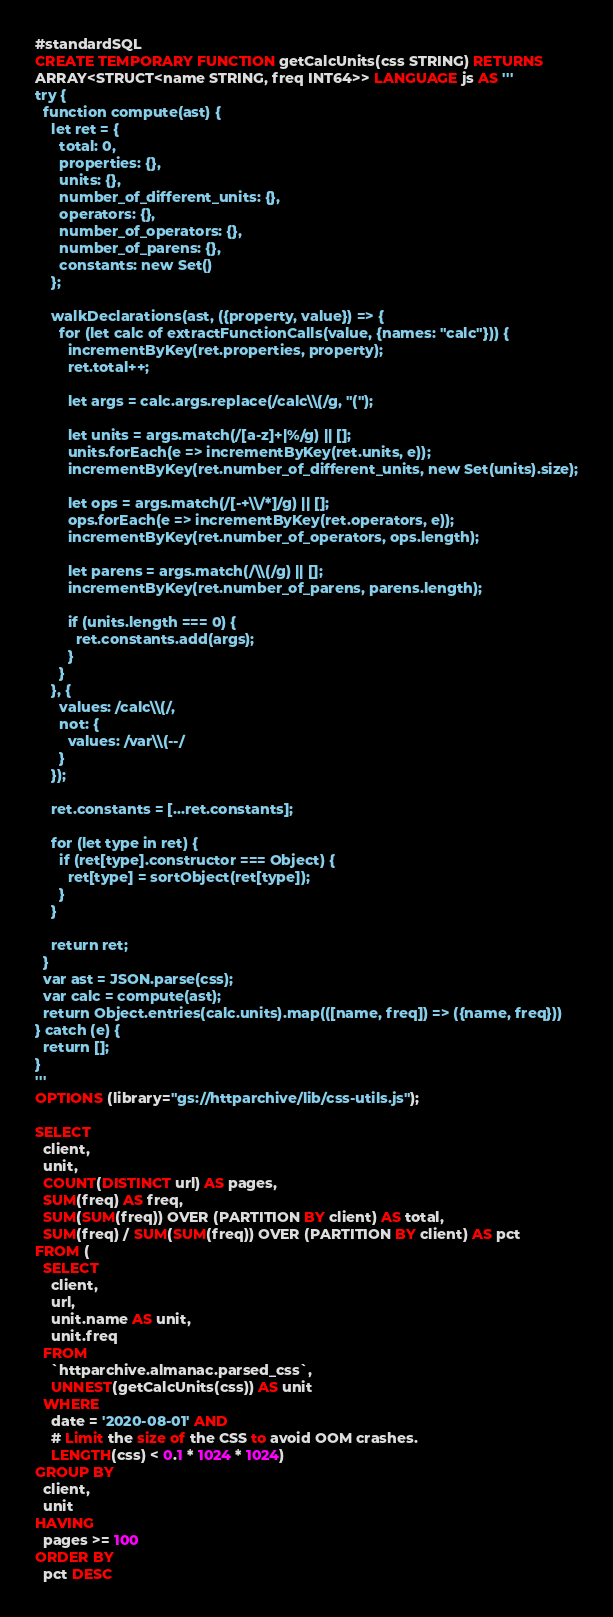<code> <loc_0><loc_0><loc_500><loc_500><_SQL_>#standardSQL
CREATE TEMPORARY FUNCTION getCalcUnits(css STRING) RETURNS
ARRAY<STRUCT<name STRING, freq INT64>> LANGUAGE js AS '''
try {
  function compute(ast) {
    let ret = {
      total: 0,
      properties: {},
      units: {},
      number_of_different_units: {},
      operators: {},
      number_of_operators: {},
      number_of_parens: {},
      constants: new Set()
    };

    walkDeclarations(ast, ({property, value}) => {
      for (let calc of extractFunctionCalls(value, {names: "calc"})) {
        incrementByKey(ret.properties, property);
        ret.total++;

        let args = calc.args.replace(/calc\\(/g, "(");

        let units = args.match(/[a-z]+|%/g) || [];
        units.forEach(e => incrementByKey(ret.units, e));
        incrementByKey(ret.number_of_different_units, new Set(units).size);

        let ops = args.match(/[-+\\/*]/g) || [];
        ops.forEach(e => incrementByKey(ret.operators, e));
        incrementByKey(ret.number_of_operators, ops.length);

        let parens = args.match(/\\(/g) || [];
        incrementByKey(ret.number_of_parens, parens.length);

        if (units.length === 0) {
          ret.constants.add(args);
        }
      }
    }, {
      values: /calc\\(/,
      not: {
        values: /var\\(--/
      }
    });

    ret.constants = [...ret.constants];

    for (let type in ret) {
      if (ret[type].constructor === Object) {
        ret[type] = sortObject(ret[type]);
      }
    }

    return ret;
  }
  var ast = JSON.parse(css);
  var calc = compute(ast);
  return Object.entries(calc.units).map(([name, freq]) => ({name, freq}))
} catch (e) {
  return [];
}
'''
OPTIONS (library="gs://httparchive/lib/css-utils.js");

SELECT
  client,
  unit,
  COUNT(DISTINCT url) AS pages,
  SUM(freq) AS freq,
  SUM(SUM(freq)) OVER (PARTITION BY client) AS total,
  SUM(freq) / SUM(SUM(freq)) OVER (PARTITION BY client) AS pct
FROM (
  SELECT
    client,
    url,
    unit.name AS unit,
    unit.freq
  FROM
    `httparchive.almanac.parsed_css`,
    UNNEST(getCalcUnits(css)) AS unit
  WHERE
    date = '2020-08-01' AND
    # Limit the size of the CSS to avoid OOM crashes.
    LENGTH(css) < 0.1 * 1024 * 1024)
GROUP BY
  client,
  unit
HAVING
  pages >= 100
ORDER BY
  pct DESC</code> 